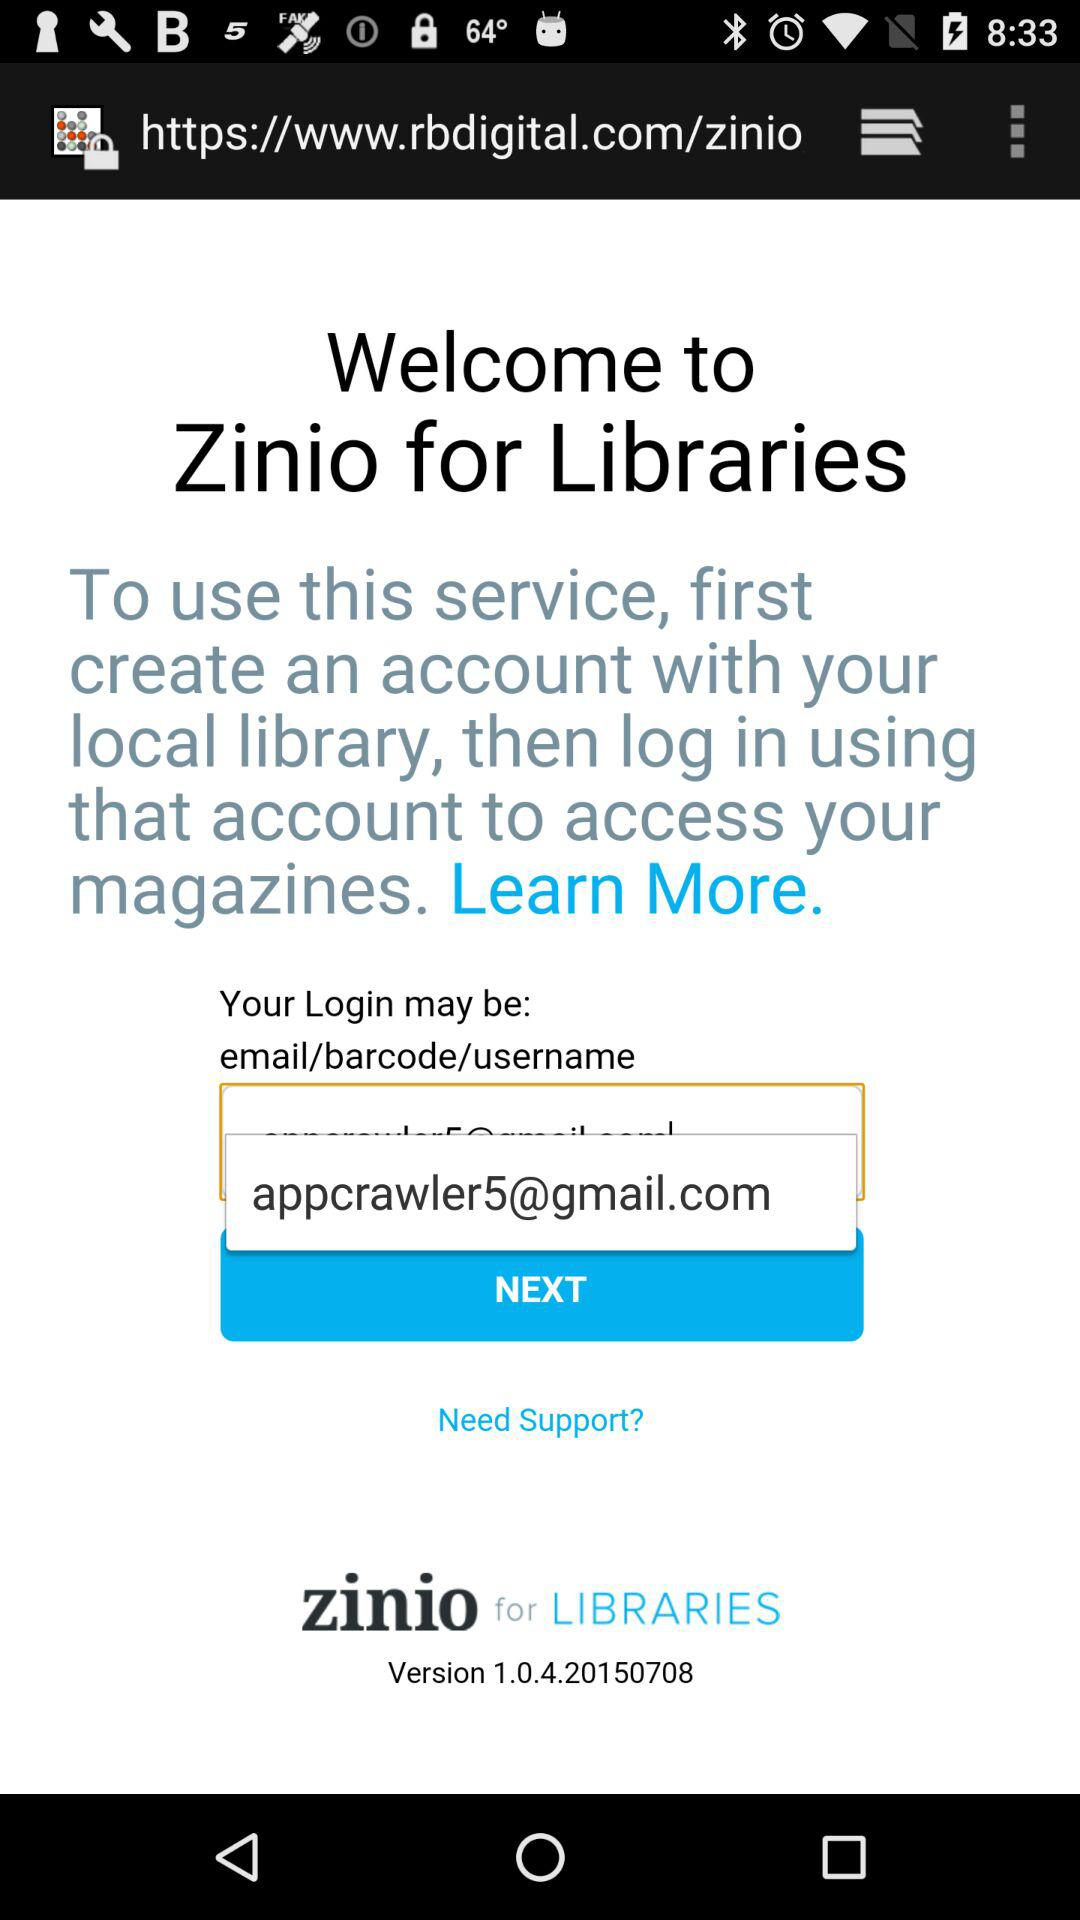What Gmail address can be used to log in? The Gmail address that can be used to log in is appcrawler5@gmail.com. 